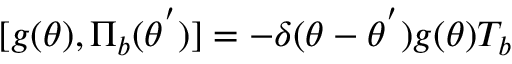<formula> <loc_0><loc_0><loc_500><loc_500>[ g ( \theta ) , { \Pi } _ { b } ( { \theta } ^ { ^ { \prime } } ) ] = - { \delta } ( { \theta } - { \theta } ^ { ^ { \prime } } ) g ( \theta ) T _ { b }</formula> 